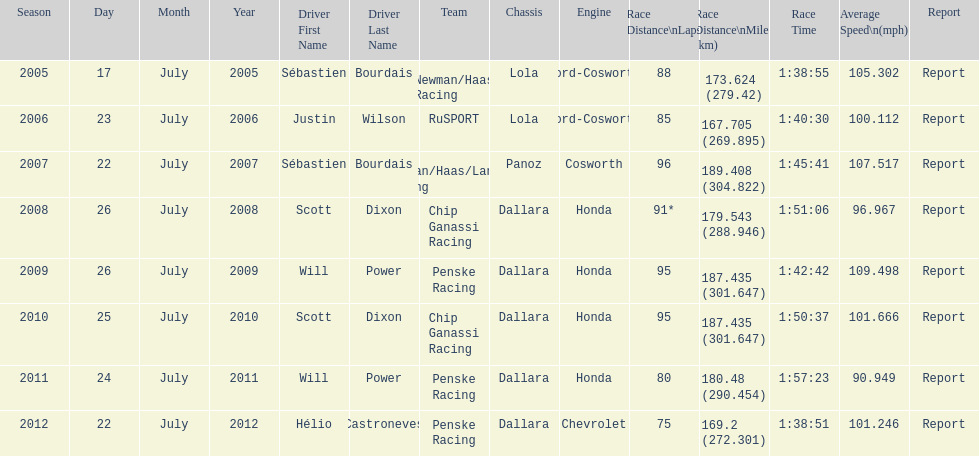How many total honda engines were there? 4. 